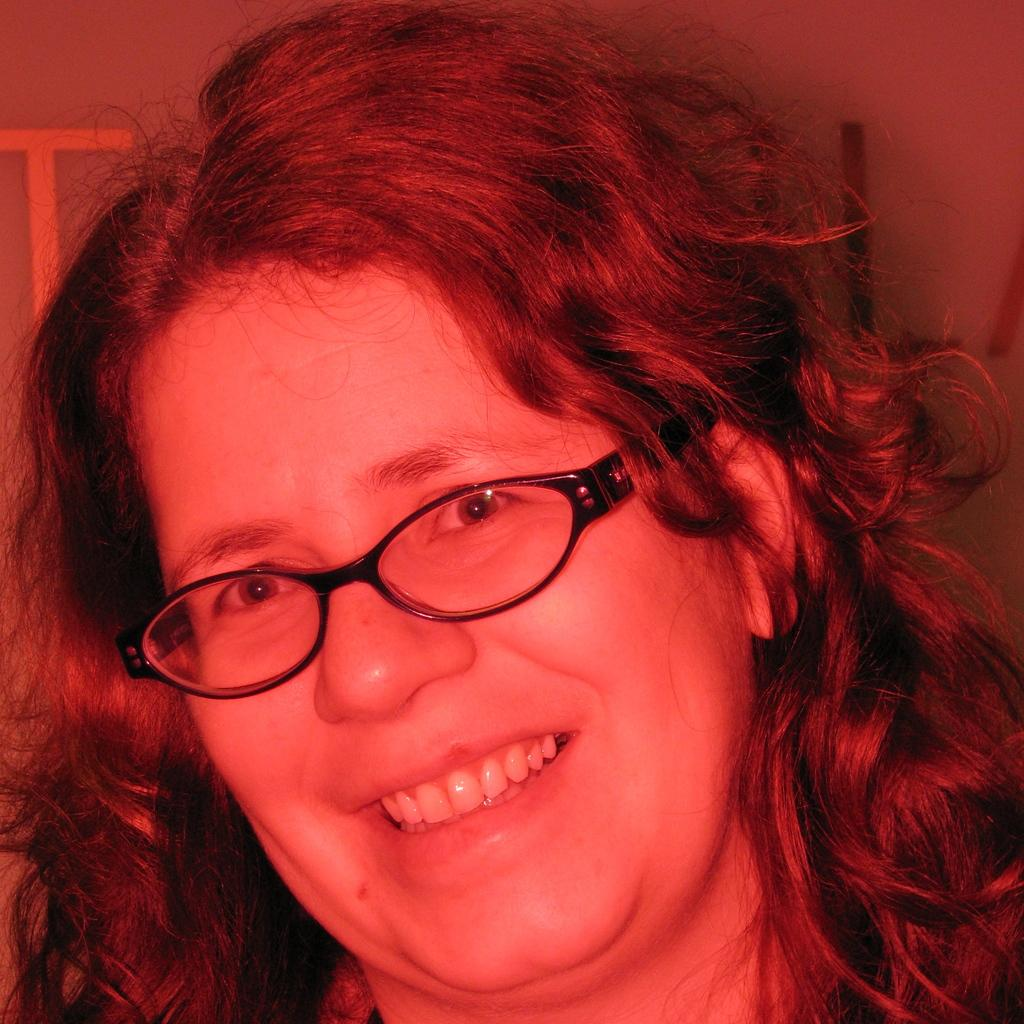Who is the main subject in the image? There is a lady in the image. What can be seen on the lady's face? The lady's face is visible in the image. What accessory is the lady wearing in the image? The lady is wearing black color spectacles. What type of hook is the lady holding in the image? There is no hook present in the image; the lady is wearing black color spectacles. How many buttons can be seen on the lady's clothing in the image? There is no information about buttons on the lady's clothing in the image. 